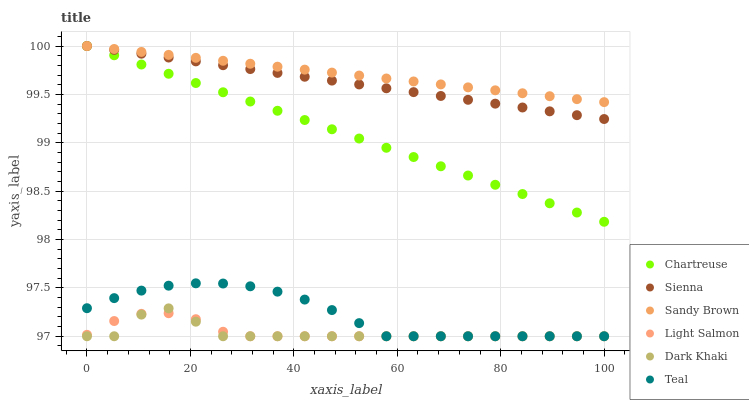Does Dark Khaki have the minimum area under the curve?
Answer yes or no. Yes. Does Sandy Brown have the maximum area under the curve?
Answer yes or no. Yes. Does Light Salmon have the minimum area under the curve?
Answer yes or no. No. Does Light Salmon have the maximum area under the curve?
Answer yes or no. No. Is Chartreuse the smoothest?
Answer yes or no. Yes. Is Dark Khaki the roughest?
Answer yes or no. Yes. Is Light Salmon the smoothest?
Answer yes or no. No. Is Light Salmon the roughest?
Answer yes or no. No. Does Dark Khaki have the lowest value?
Answer yes or no. Yes. Does Sienna have the lowest value?
Answer yes or no. No. Does Sandy Brown have the highest value?
Answer yes or no. Yes. Does Light Salmon have the highest value?
Answer yes or no. No. Is Dark Khaki less than Sandy Brown?
Answer yes or no. Yes. Is Sienna greater than Light Salmon?
Answer yes or no. Yes. Does Light Salmon intersect Teal?
Answer yes or no. Yes. Is Light Salmon less than Teal?
Answer yes or no. No. Is Light Salmon greater than Teal?
Answer yes or no. No. Does Dark Khaki intersect Sandy Brown?
Answer yes or no. No. 